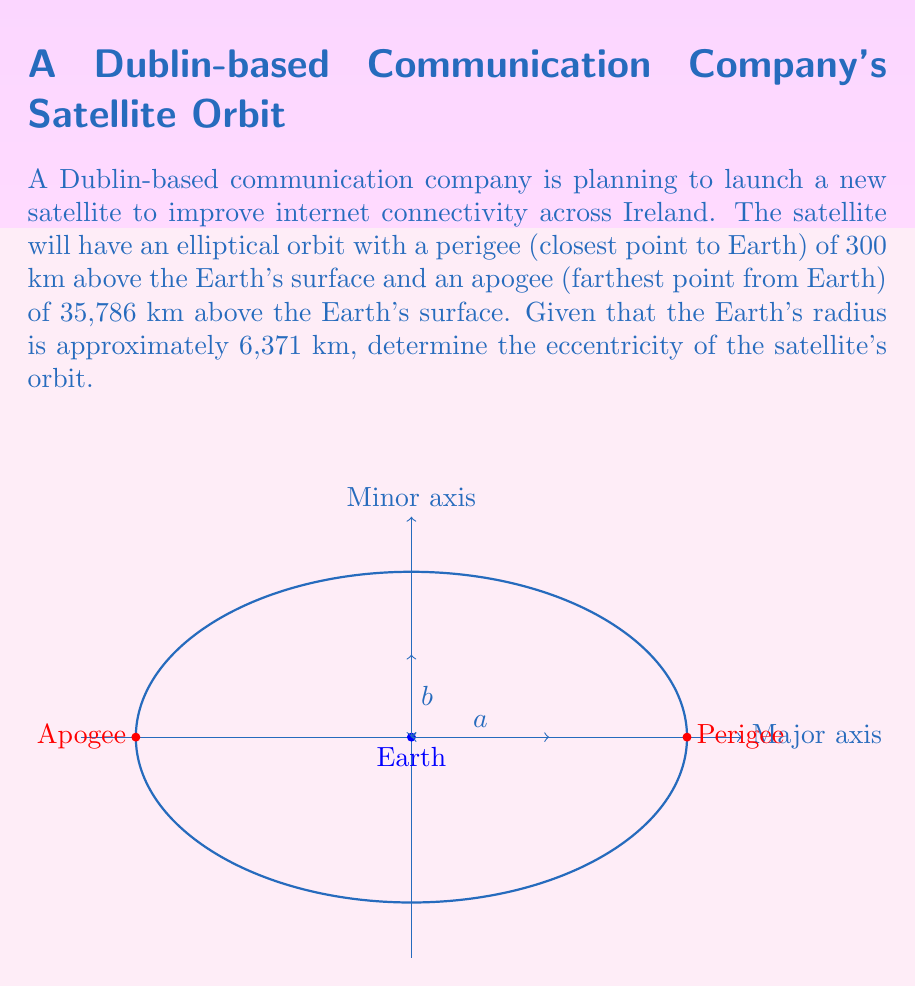Can you answer this question? Let's approach this step-by-step:

1) First, we need to calculate the semi-major axis $a$ of the elliptical orbit. The semi-major axis is the average of the apogee and perigee distances from the center of the Earth:

   $$a = \frac{(r_p + R_E) + (r_a + R_E)}{2}$$

   Where $r_p$ is the perigee altitude, $r_a$ is the apogee altitude, and $R_E$ is the Earth's radius.

2) Let's substitute the values:

   $$a = \frac{(300 + 6371) + (35786 + 6371)}{2} = \frac{6671 + 42157}{2} = 24414 \text{ km}$$

3) Now, we need to calculate the distance from the center of the Earth to the center of the ellipse, which is the focal distance $c$:

   $$c = a - (R_E + r_p) = 24414 - (6371 + 300) = 17743 \text{ km}$$

4) The eccentricity $e$ of an ellipse is defined as the ratio of the focal distance to the semi-major axis:

   $$e = \frac{c}{a}$$

5) Substituting our values:

   $$e = \frac{17743}{24414} \approx 0.7267$$

Thus, the eccentricity of the satellite's orbit is approximately 0.7267.
Answer: $e \approx 0.7267$ 